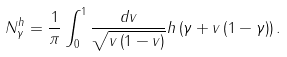<formula> <loc_0><loc_0><loc_500><loc_500>N _ { \gamma } ^ { h } = \frac { 1 } { \pi } \int _ { 0 } ^ { 1 } \frac { d v } { \sqrt { v \left ( 1 - v \right ) } } h \left ( \gamma + v \left ( 1 - \gamma \right ) \right ) .</formula> 